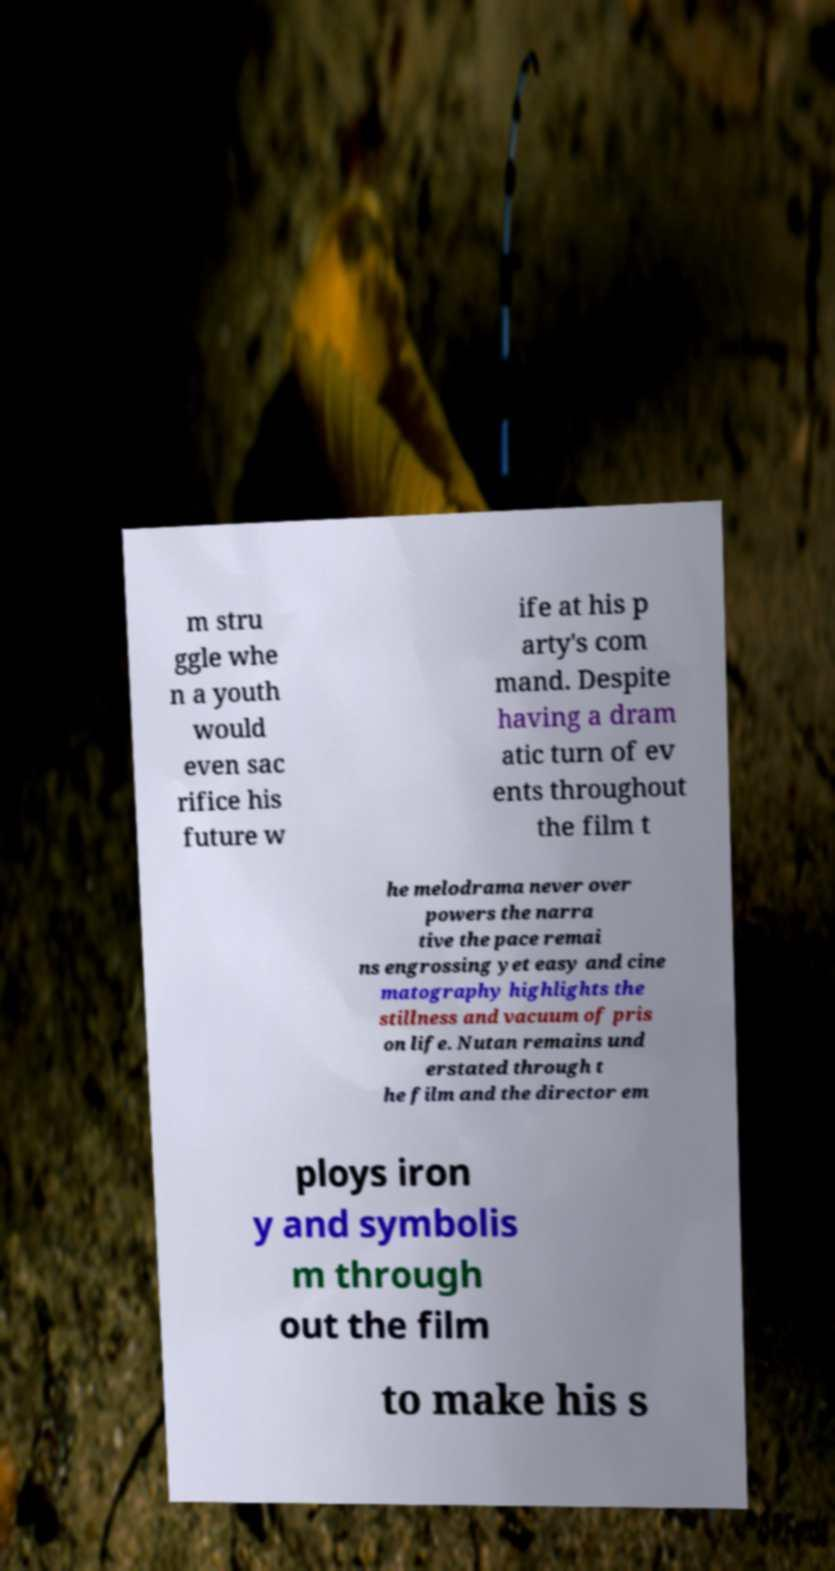I need the written content from this picture converted into text. Can you do that? m stru ggle whe n a youth would even sac rifice his future w ife at his p arty's com mand. Despite having a dram atic turn of ev ents throughout the film t he melodrama never over powers the narra tive the pace remai ns engrossing yet easy and cine matography highlights the stillness and vacuum of pris on life. Nutan remains und erstated through t he film and the director em ploys iron y and symbolis m through out the film to make his s 